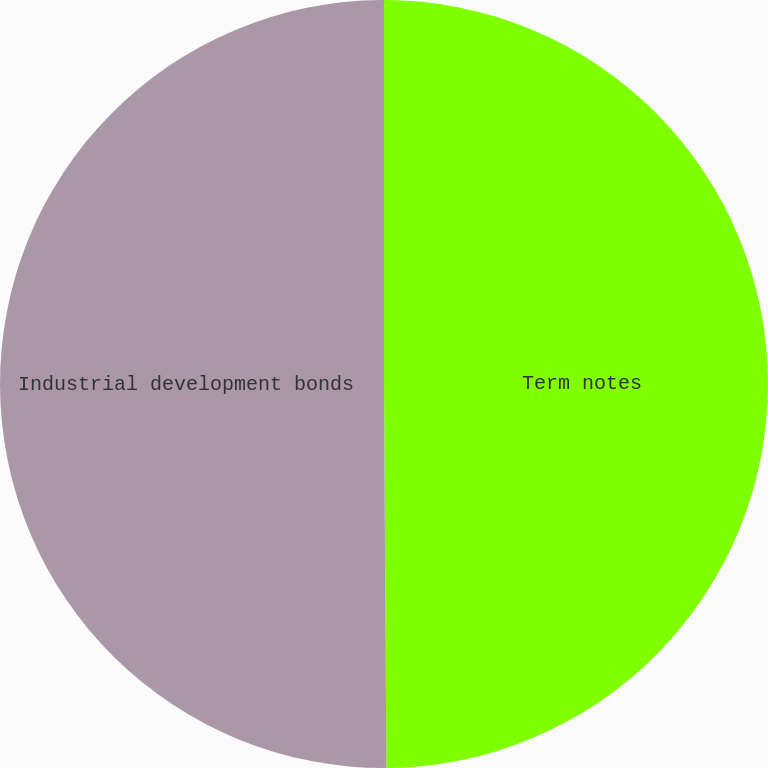<chart> <loc_0><loc_0><loc_500><loc_500><pie_chart><fcel>Term notes<fcel>Industrial development bonds<nl><fcel>49.9%<fcel>50.1%<nl></chart> 